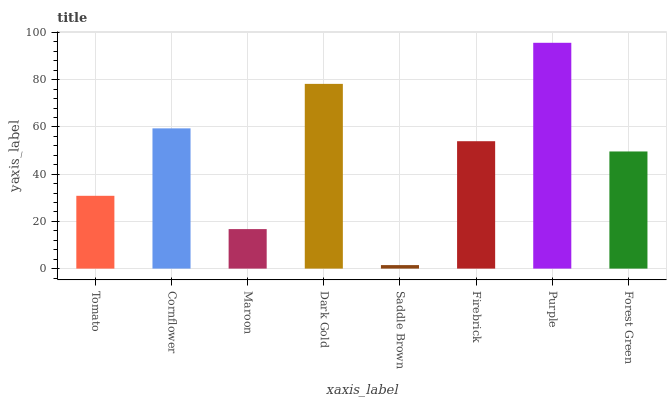Is Cornflower the minimum?
Answer yes or no. No. Is Cornflower the maximum?
Answer yes or no. No. Is Cornflower greater than Tomato?
Answer yes or no. Yes. Is Tomato less than Cornflower?
Answer yes or no. Yes. Is Tomato greater than Cornflower?
Answer yes or no. No. Is Cornflower less than Tomato?
Answer yes or no. No. Is Firebrick the high median?
Answer yes or no. Yes. Is Forest Green the low median?
Answer yes or no. Yes. Is Tomato the high median?
Answer yes or no. No. Is Firebrick the low median?
Answer yes or no. No. 